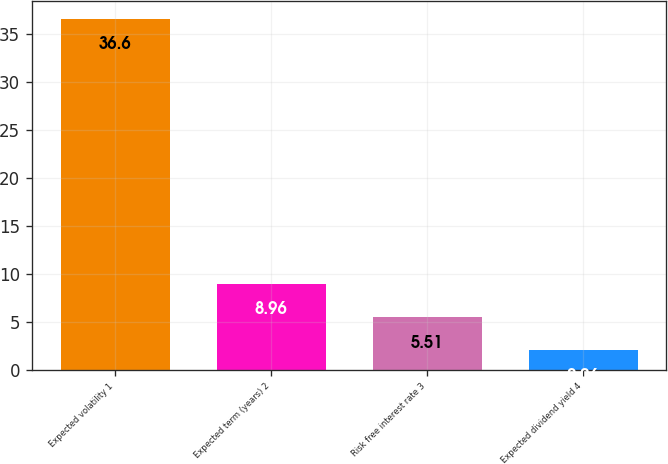<chart> <loc_0><loc_0><loc_500><loc_500><bar_chart><fcel>Expected volatility 1<fcel>Expected term (years) 2<fcel>Risk free interest rate 3<fcel>Expected dividend yield 4<nl><fcel>36.6<fcel>8.96<fcel>5.51<fcel>2.06<nl></chart> 